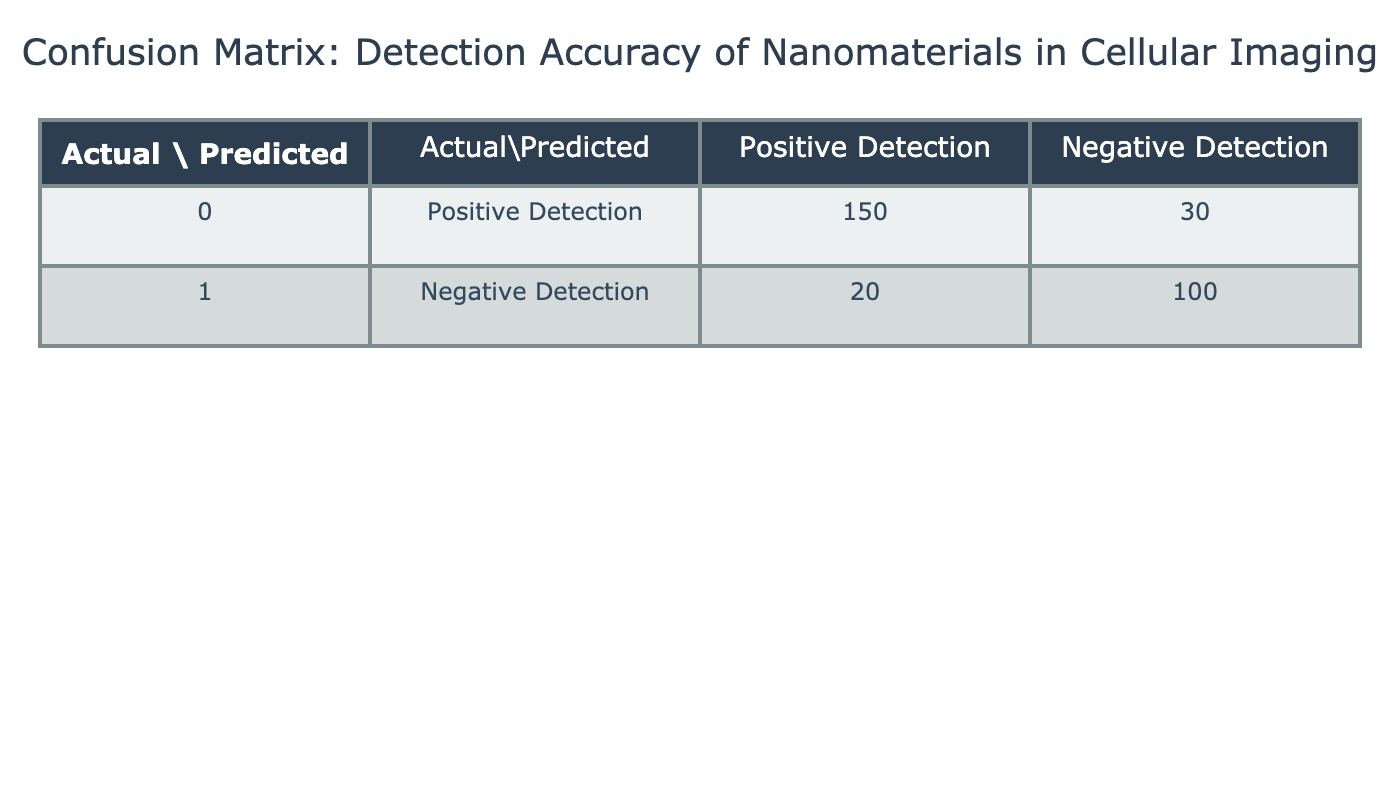What is the total number of positive detections? The number of positive detections can be found by looking at the row for "Positive Detection". Adding the values from that row gives 150 (true positives) + 30 (false negatives) = 180.
Answer: 180 What is the number of negative detections? To find the number of negative detections, we look at the "Negative Detection" row. Adding these values gives 20 (false positives) + 100 (true negatives) = 120.
Answer: 120 What is the total number of predictions made? To calculate the total number of predictions, we sum all the values in the table: 150 + 30 + 20 + 100 = 300.
Answer: 300 What is the accuracy of the detection system? Accuracy is calculated by the formula: (True Positives + True Negatives) / Total Predictions. In this case, (150 + 100) / 300 = 0.8333, which translates to an accuracy of approximately 83.33%.
Answer: 83.33% Are there more true positive detections than true negatives? The values for true positive detections and true negatives are 150 and 100, respectively. Since 150 is greater than 100, the statement is true.
Answer: Yes Is the number of false negatives greater than the number of false positives? The number of false negatives is 30, and the number of false positives is 20. Since 30 is greater than 20, the statement is true.
Answer: Yes What percentage of the total detections are false positives? To determine the percentage of false positives, we can use the formula: (False Positives / Total Predictions) * 100. Here, it is (20 / 300) * 100 = 6.67%.
Answer: 6.67% What is the difference between true positives and true negatives? The difference can be calculated as True Positives (150) - True Negatives (100), which equals 150 - 100 = 50.
Answer: 50 How many more true positives are there compared to false negatives? Finding this requires subtracting the number of false negatives (30) from the number of true positives (150): 150 - 30 = 120.
Answer: 120 